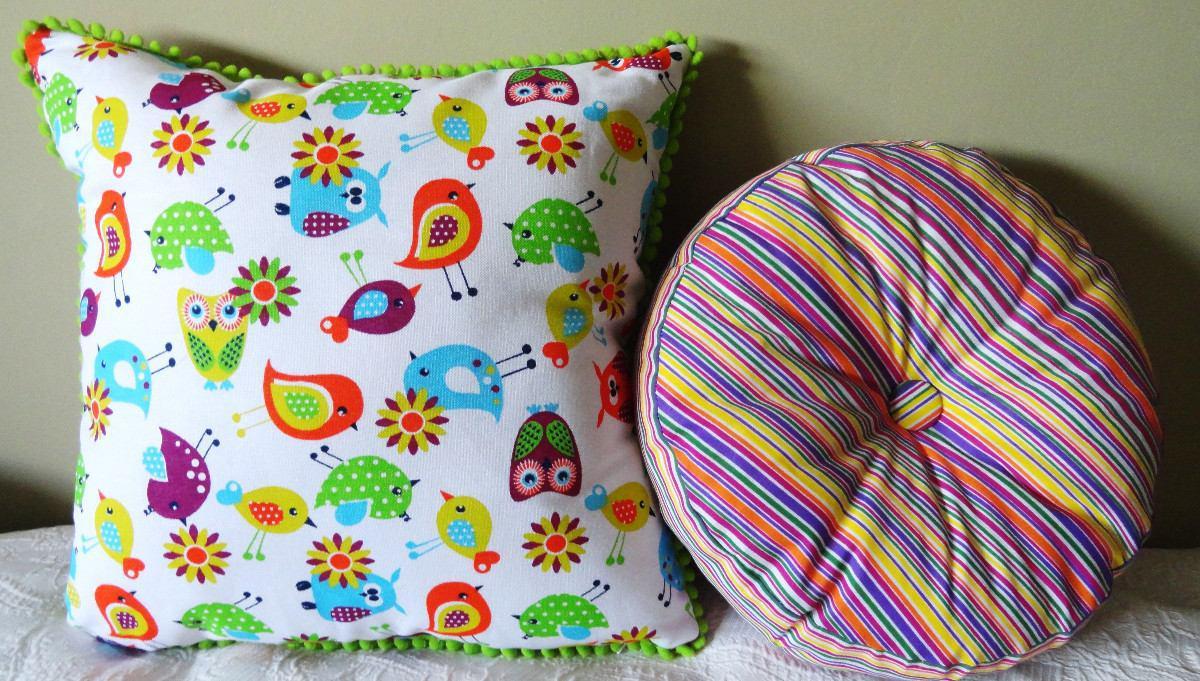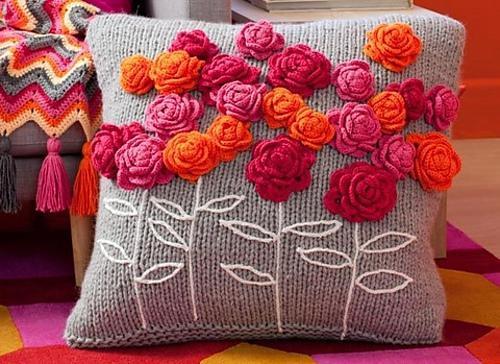The first image is the image on the left, the second image is the image on the right. Examine the images to the left and right. Is the description "At least one of the sofas is a solid pink color." accurate? Answer yes or no. No. 